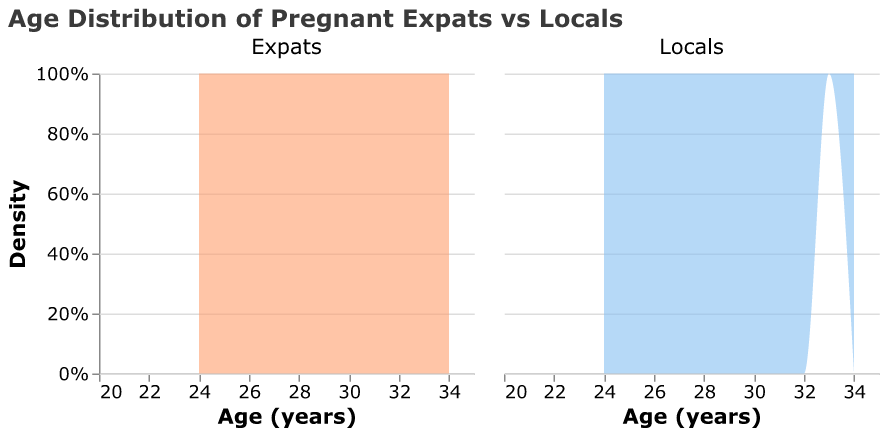What is the title of the figure? The title of the figure is displayed at the top and it reads "Age Distribution of Pregnant Expats vs Locals."
Answer: Age Distribution of Pregnant Expats vs Locals What colors are used to represent Expats and Locals in the plot? The legend of the plot uses colors to differentiate between the two groups; Expats are represented by an orange shade, and Locals by a light blue shade.
Answer: Expats are orange, Locals are light blue Which group has the highest density peak in the age range 27-28 years? By examining the density peaks within overlapping age ranges of both groups, it can be seen that Locals have a higher density peak in the age range 27-28 years compared to Expats.
Answer: Locals At what age do both groups show the most overlap in their density distributions? The ages where the orange (Expats) and light blue (Locals) areas have considerable overlap can be identified from the plot, particularly around the age of 29-30 years.
Answer: 29-30 years How many total data points are presented in the plot for each group? By counting the individual data points provided in the dataset portion grouped by “Expats” and “Locals,” there are 20 data points for Expats and 20 for Locals.
Answer: 20 for Expats, 20 for Locals Which group has a broader age range? Looking at the width of the density plots along the x-axis, both the Expats and Locals cover the same age range from 24 to 34 years, indicating equal age ranges.
Answer: Both What is the highest age recorded for both groups? The highest age value along the x-axis where density is observed for both groups is 34 years as per the density representation in the plot.
Answer: 34 years Is there a noticeable age where Locals have no density representation but Expats do? By scanning across the age range in the plot, it can be noted that both groups have data points covering all ages; there is no age where Locals lack representation.
Answer: No What's the comparison of density between ages 25 and 26 for both groups? Observing the density peaks at ages 25 and 26 shows that the density of Expats is slightly higher than Locals at age 26, while at age 25, the densities are nearly equal.
Answer: Expats higher at 26, equal at 25 What are the common age ranges conveyed by both groups? Assessing the overlap of density distributions along the x-axis reveals that both groups commonly cover an age range from 24 to 34 years, with significant density.
Answer: 24-34 years 